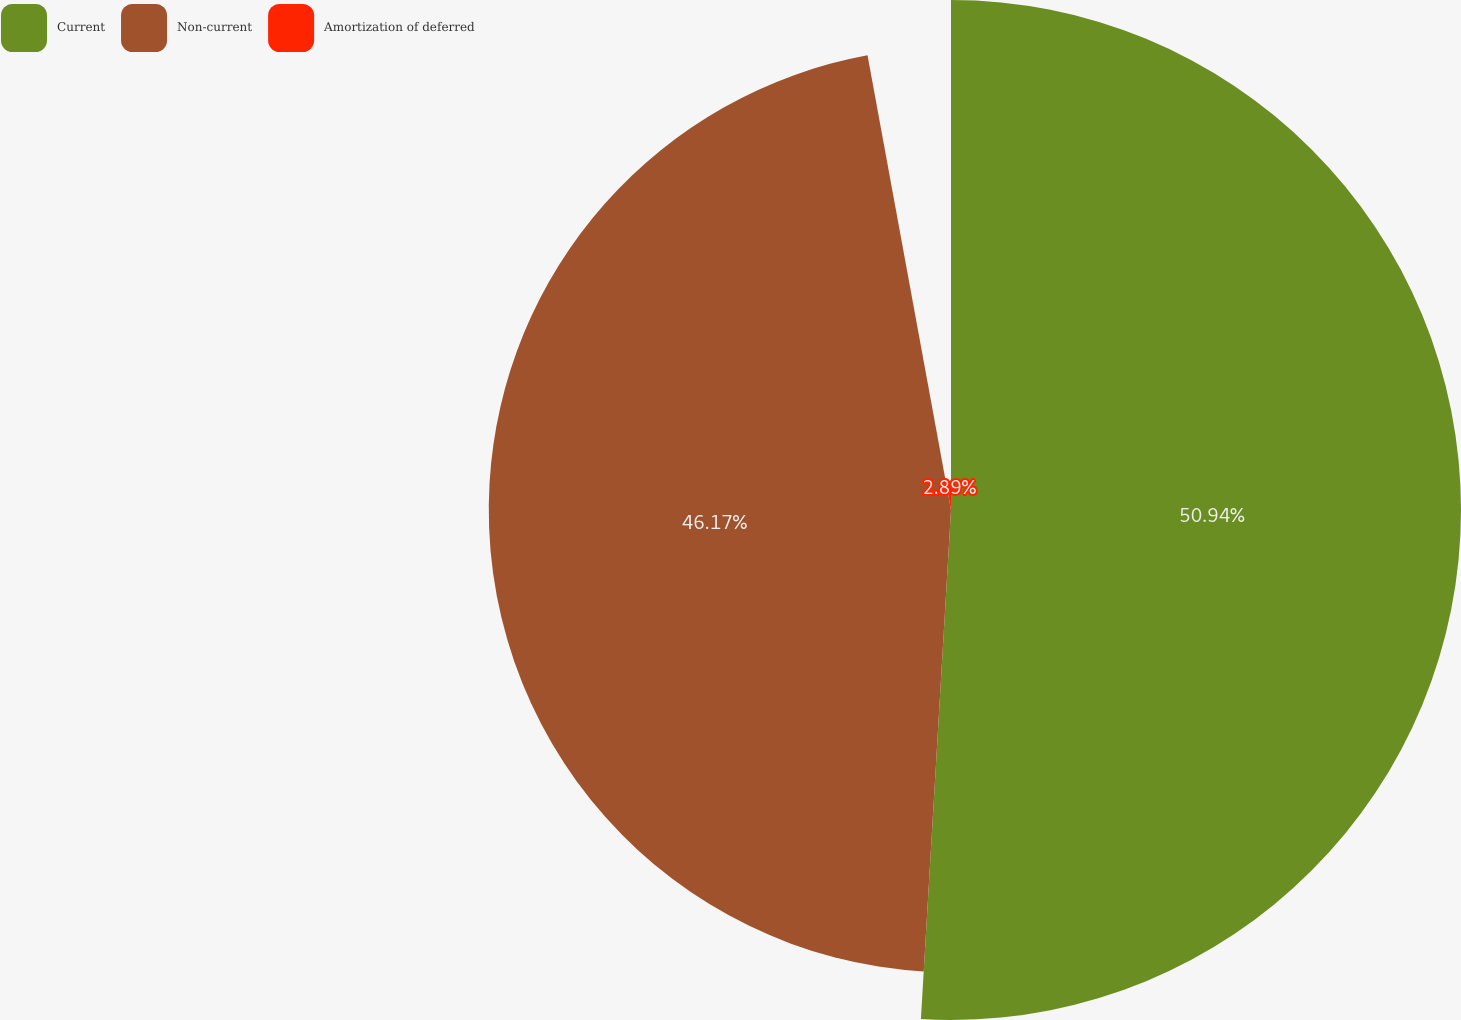<chart> <loc_0><loc_0><loc_500><loc_500><pie_chart><fcel>Current<fcel>Non-current<fcel>Amortization of deferred<nl><fcel>50.94%<fcel>46.17%<fcel>2.89%<nl></chart> 